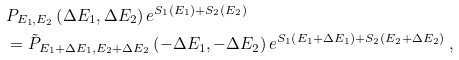Convert formula to latex. <formula><loc_0><loc_0><loc_500><loc_500>& P _ { E _ { 1 } , E _ { 2 } } \left ( \Delta E _ { 1 } , \Delta E _ { 2 } \right ) e ^ { S _ { 1 } \left ( E _ { 1 } \right ) + S _ { 2 } \left ( E _ { 2 } \right ) } \\ & = \tilde { P } _ { E _ { 1 } + \Delta E _ { 1 } , E _ { 2 } + \Delta E _ { 2 } } \left ( - \Delta E _ { 1 } , - \Delta E _ { 2 } \right ) e ^ { S _ { 1 } \left ( E _ { 1 } + \Delta E _ { 1 } \right ) + S _ { 2 } \left ( E _ { 2 } + \Delta E _ { 2 } \right ) } \ ,</formula> 